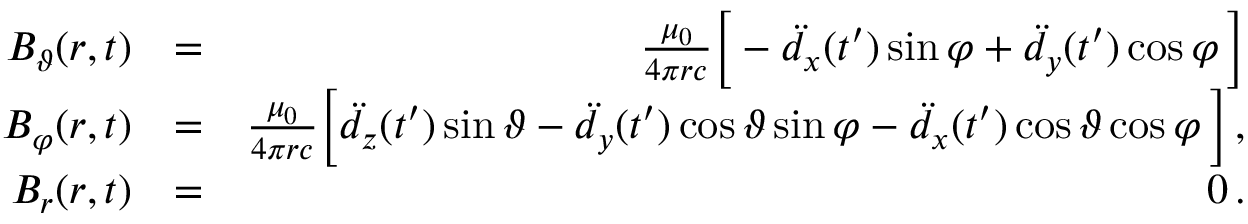Convert formula to latex. <formula><loc_0><loc_0><loc_500><loc_500>\begin{array} { r l r } { B _ { \vartheta } ( r , t ) } & { = } & { \frac { \mu _ { 0 } } { 4 \pi r c } \left [ - \ddot { d } _ { x } ( t ^ { \prime } ) \sin \varphi + \ddot { d } _ { y } ( t ^ { \prime } ) \cos \varphi \, \right ] } \\ { B _ { \varphi } ( r , t ) } & { = } & { \frac { \mu _ { 0 } } { 4 \pi r c } \left [ \ddot { d } _ { z } ( t ^ { \prime } ) \sin \vartheta - \ddot { d } _ { y } ( t ^ { \prime } ) \cos \vartheta \sin \varphi - \ddot { d } _ { x } ( t ^ { \prime } ) \cos \vartheta \cos \varphi \, \right ] \, , } \\ { B _ { r } ( r , t ) } & { = } & { 0 \, . } \end{array}</formula> 